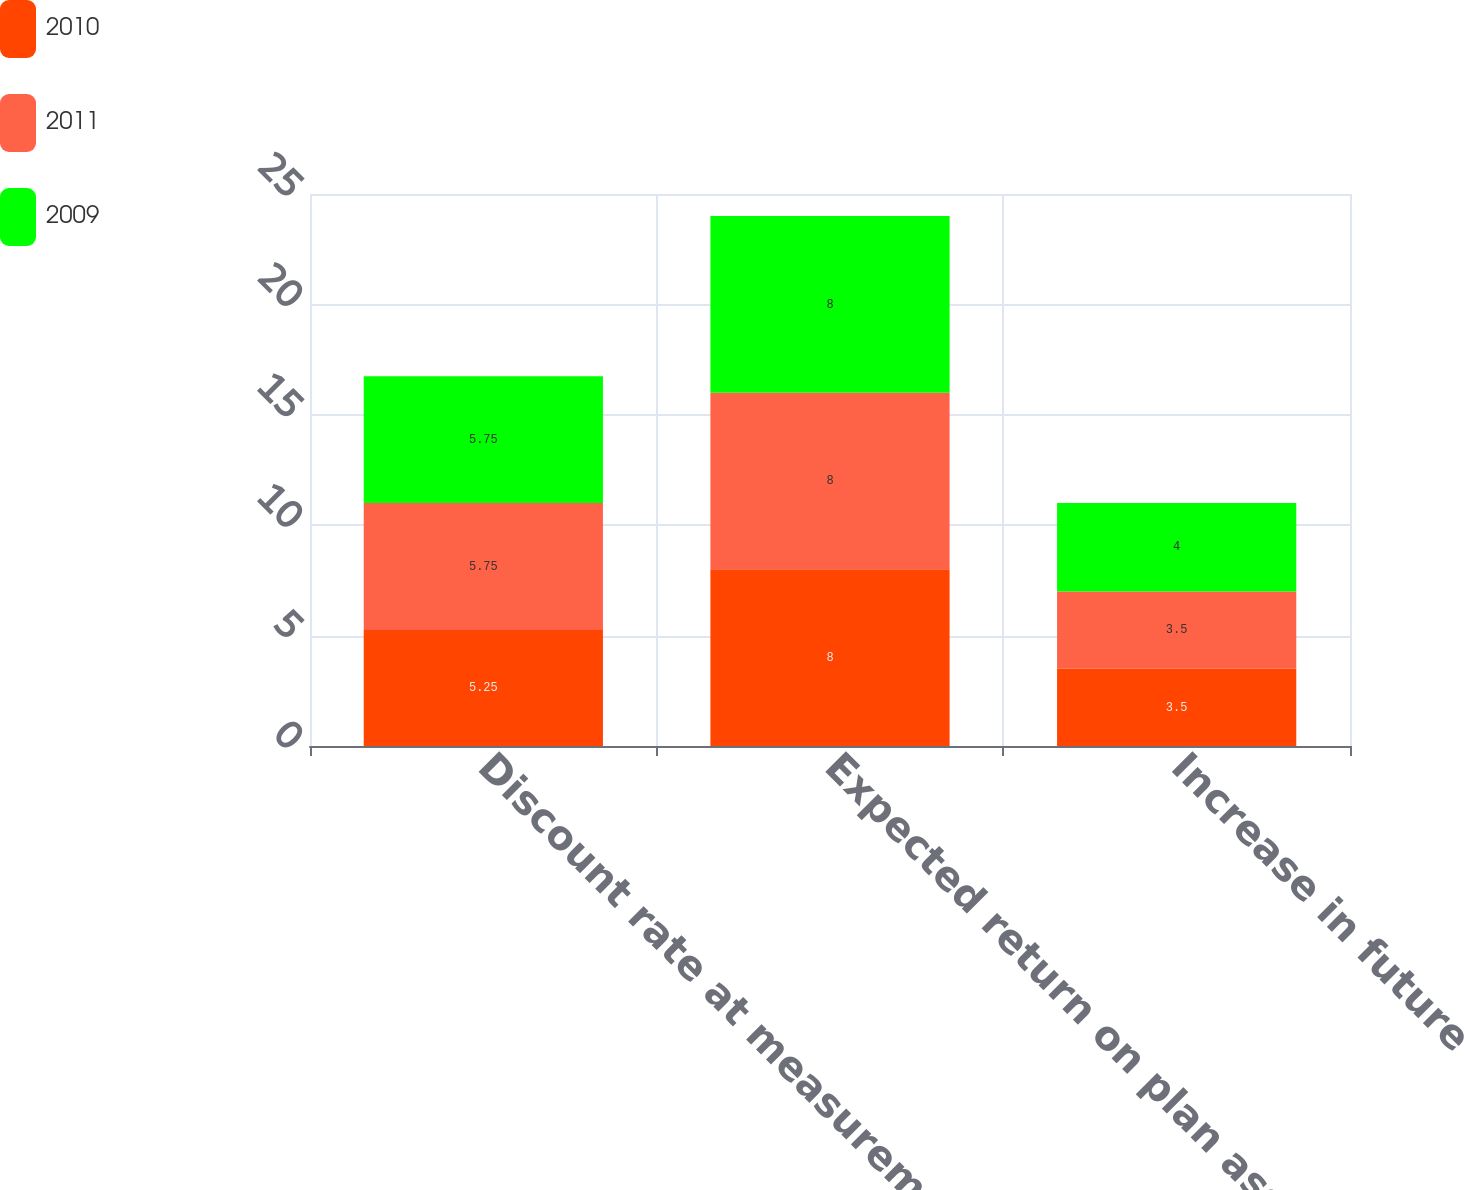Convert chart. <chart><loc_0><loc_0><loc_500><loc_500><stacked_bar_chart><ecel><fcel>Discount rate at measurement<fcel>Expected return on plan assets<fcel>Increase in future<nl><fcel>2010<fcel>5.25<fcel>8<fcel>3.5<nl><fcel>2011<fcel>5.75<fcel>8<fcel>3.5<nl><fcel>2009<fcel>5.75<fcel>8<fcel>4<nl></chart> 